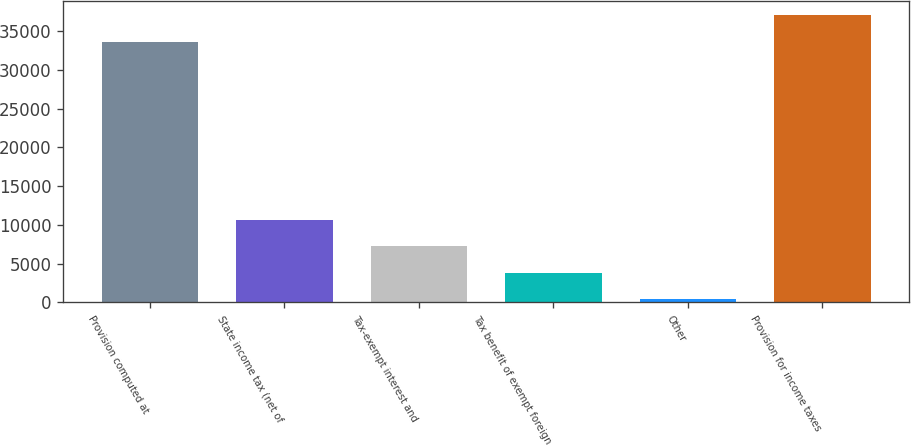Convert chart to OTSL. <chart><loc_0><loc_0><loc_500><loc_500><bar_chart><fcel>Provision computed at<fcel>State income tax (net of<fcel>Tax-exempt interest and<fcel>Tax benefit of exempt foreign<fcel>Other<fcel>Provision for income taxes<nl><fcel>33649<fcel>10639.9<fcel>7215.6<fcel>3791.3<fcel>367<fcel>37073.3<nl></chart> 